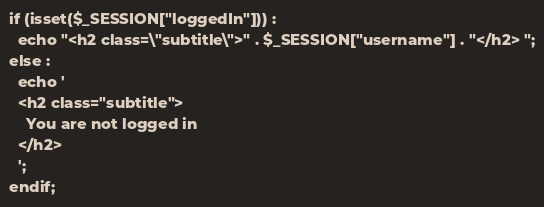<code> <loc_0><loc_0><loc_500><loc_500><_PHP_>if (isset($_SESSION["loggedIn"])) :
  echo "<h2 class=\"subtitle\">" . $_SESSION["username"] . "</h2> ";
else :
  echo '
  <h2 class="subtitle">
    You are not logged in
  </h2>
  ';
endif;
</code> 